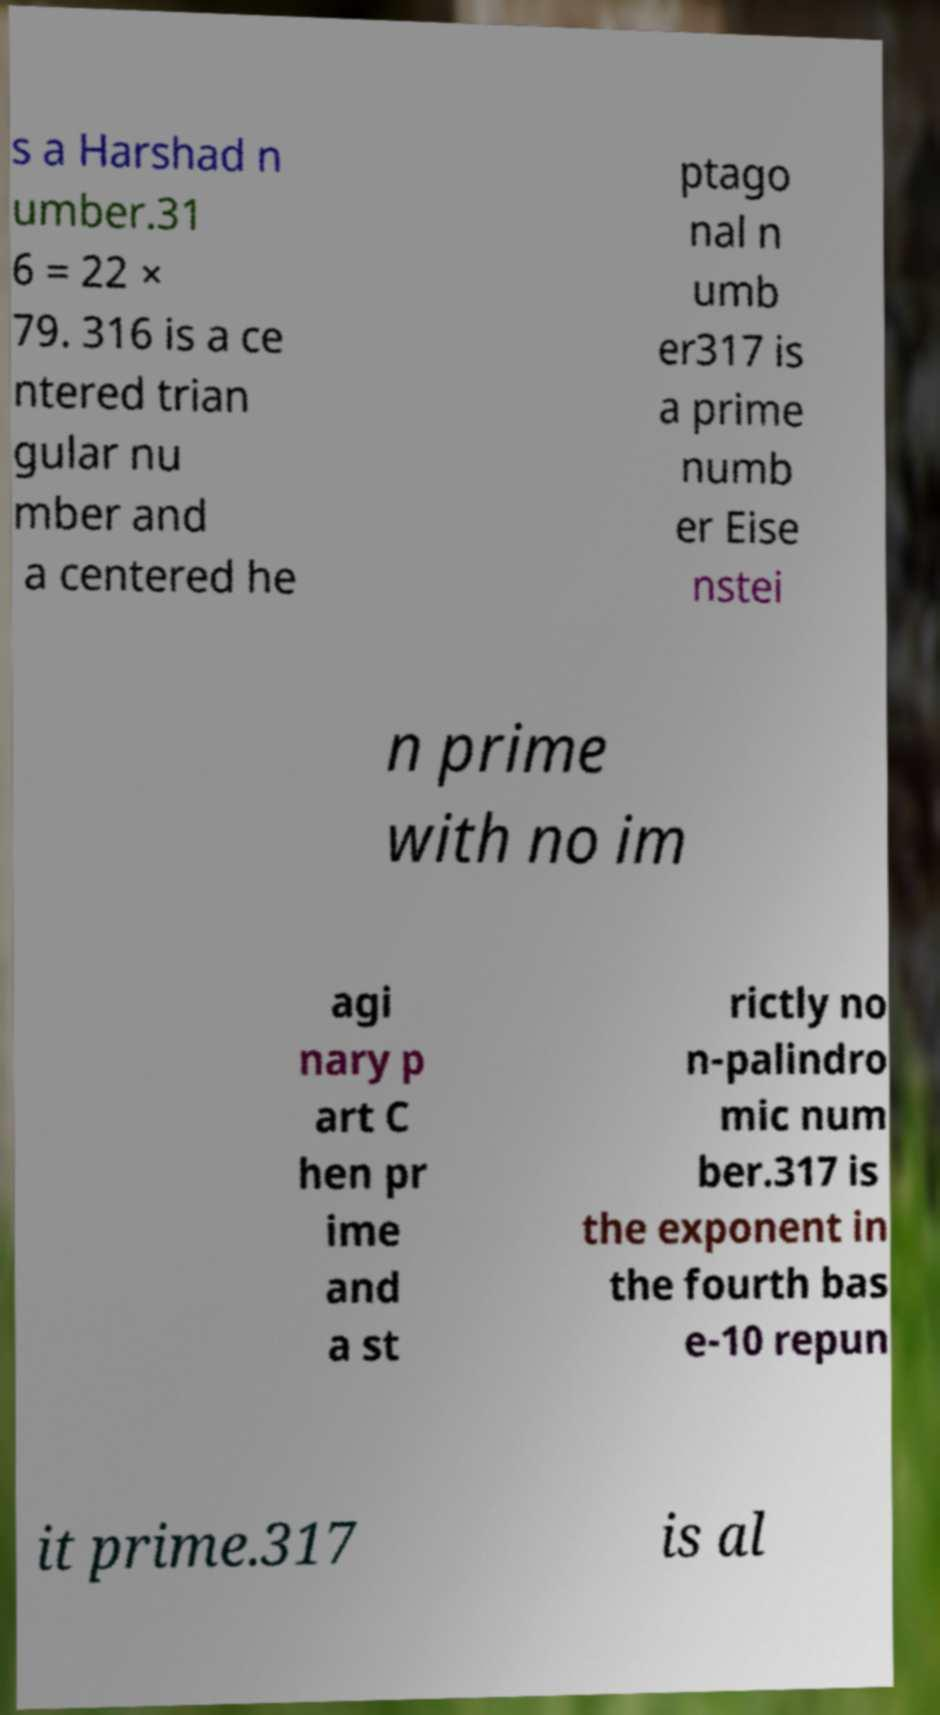Please identify and transcribe the text found in this image. s a Harshad n umber.31 6 = 22 × 79. 316 is a ce ntered trian gular nu mber and a centered he ptago nal n umb er317 is a prime numb er Eise nstei n prime with no im agi nary p art C hen pr ime and a st rictly no n-palindro mic num ber.317 is the exponent in the fourth bas e-10 repun it prime.317 is al 